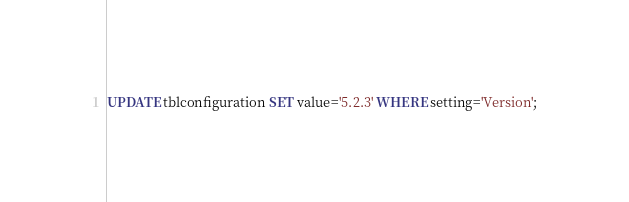<code> <loc_0><loc_0><loc_500><loc_500><_SQL_>UPDATE tblconfiguration SET value='5.2.3' WHERE setting='Version';</code> 